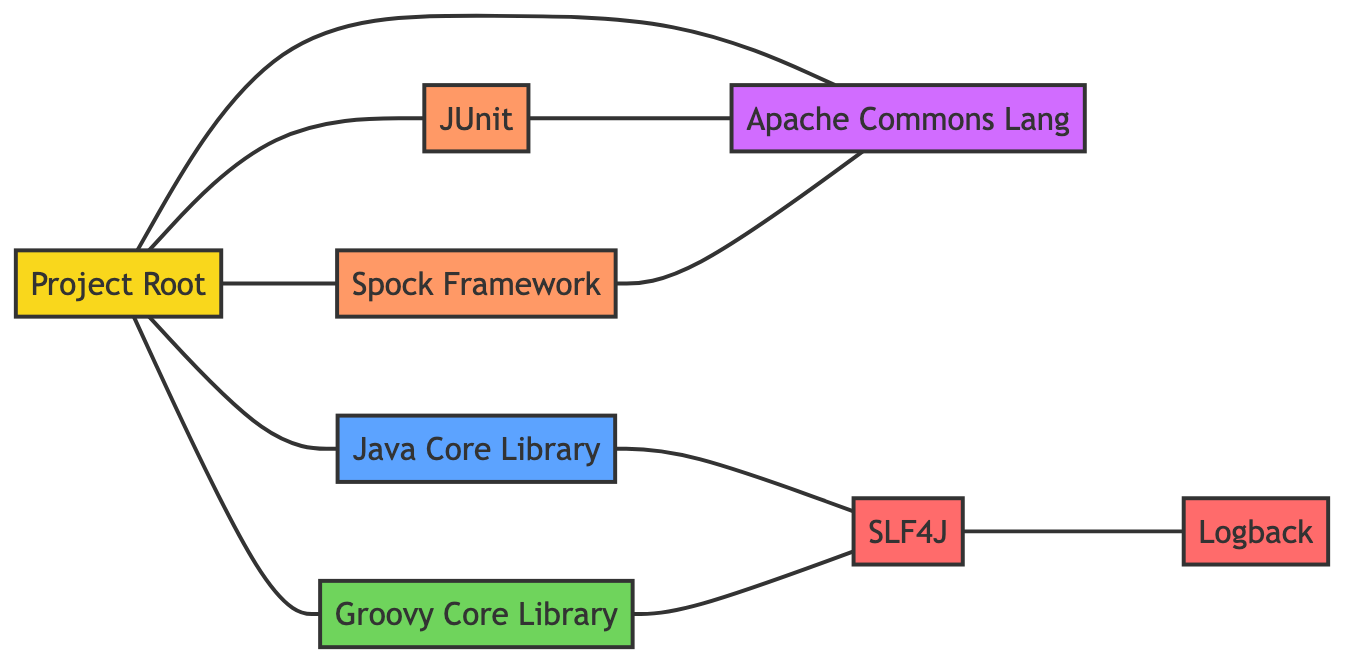What is the total number of nodes in the diagram? The nodes are identified as "Project Root," "Java Core Library," "Groovy Core Library," "Apache Commons Lang," "JUnit," "Spock Framework," "SLF4J," and "Logback." Counting these, there are eight nodes in total.
Answer: 8 Which library is connected to both Java Core Library and Groovy Core Library? By inspecting the connections (edges) from both the "Java Core Library" and "Groovy Core Library," it can be observed that "SLF4J" connects to both of these libraries.
Answer: SLF4J What is the relationship between JUnit and Apache Commons Lang? The diagram shows a direct edge connecting "JUnit" to "Apache Commons Lang," indicating that they are directly related.
Answer: Directly connected How many testing libraries are present in this dependency graph? The testing libraries in the graph are "JUnit" and "Spock Framework." There are two such libraries.
Answer: 2 Which node has the most connections? By examining the edges, "Project Root" connects to five other nodes: "Java Core Library," "Groovy Core Library," "Apache Commons Lang," "JUnit," and "Spock Framework," making it the node with the most connections.
Answer: Project Root Is Logback connected to any core library directly? The diagram shows that "Logback" is connected to "SLF4J," but there are no direct connections from "Logback" to either core library ("Java Core Library" or "Groovy Core Library").
Answer: No What type of library is Apache Commons Lang categorized as? According to the diagram's classification, "Apache Commons Lang" is designated as a utility library.
Answer: Utility Which two nodes are connected to the SLF4J node? Tracing the edges, "SLF4J" has two connections: one to "Java Core Library" and another to "Groovy Core Library."
Answer: Java Core Library and Groovy Core Library How many edges are there in the graph? The edges connect the various nodes. Listing them one by one — there are a total of 10 edges present in the diagram.
Answer: 10 